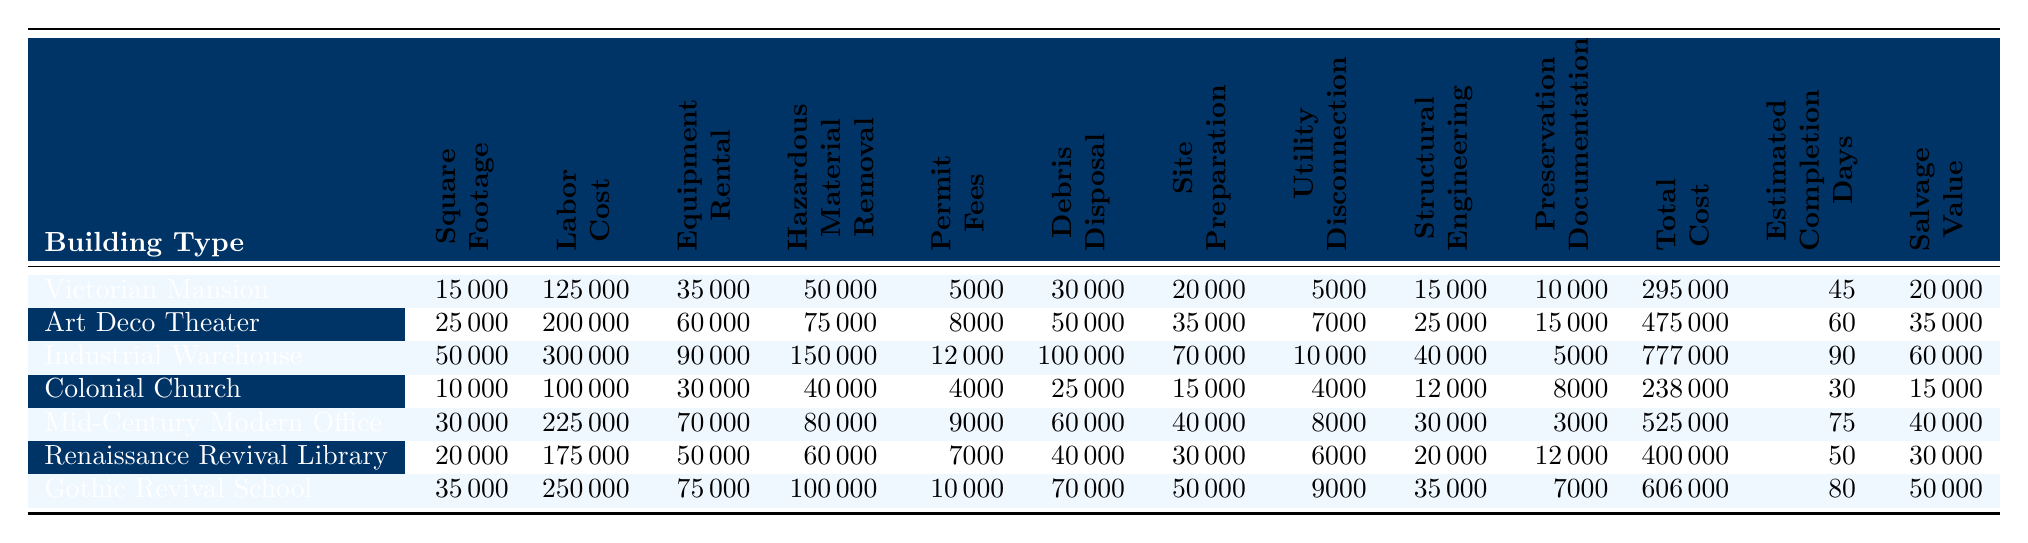What is the total cost of demolishing the Industrial Warehouse? The total cost for the Industrial Warehouse is listed directly in the table under the "Total Cost" column, which shows 777,000.
Answer: 777000 Which building type has the highest labor cost? By comparing the "Labor Cost" values, the Industrial Warehouse has the highest cost at 300,000.
Answer: Industrial Warehouse What is the average square footage of all buildings in the table? First, add all the square footages: 15000 + 25000 + 50000 + 10000 + 30000 + 20000 + 35000 = 185000. Then divide this by the number of buildings, which is 7: 185000 / 7 = 26428.57.
Answer: 26428.57 Does the Colonial Church have the lowest total cost among the buildings listed? The total cost for the Colonial Church is 238,000, which is lower than all the other buildings listed in the table.
Answer: Yes What is the total labor cost for demolishing all buildings combined? Adding all the "Labor Cost" values together: 125000 + 200000 + 300000 + 100000 + 225000 + 175000 + 250000 = 1,175,000.
Answer: 1175000 What is the correlation between high square footage and total cost? By examining the table, it appears that larger buildings, like the Industrial Warehouse (50,000 sq ft) and Gothic Revival School (35,000 sq ft), have higher total costs. Specifically, the Industrial Warehouse has the highest total cost at 777,000, indicating that there is a trend where higher square footage typically correlates with higher total demolition costs, but further analysis or statistical correlation would be required for a definitive conclusion.
Answer: Positive correlation What was the permit fee for the Art Deco Theater? The permit fee for the Art Deco Theater is stated in the "Permit Fees" column, which is 8,000.
Answer: 8000 How much is the salvage value for the Renaissance Revival Library? The salvage value is listed in the last column for the Renaissance Revival Library, which shows 30,000.
Answer: 30000 Which building has the highest estimated completion days? Looking at the "Estimated Completion Days," the Industrial Warehouse has the highest at 90 days.
Answer: Industrial Warehouse What is the difference in total cost between the Victorian Mansion and the Mid-Century Modern Office? The total cost of the Victorian Mansion is 295,000 and the Mid-Century Modern Office is 525,000. The difference is 525,000 - 295,000 = 230,000.
Answer: 230000 